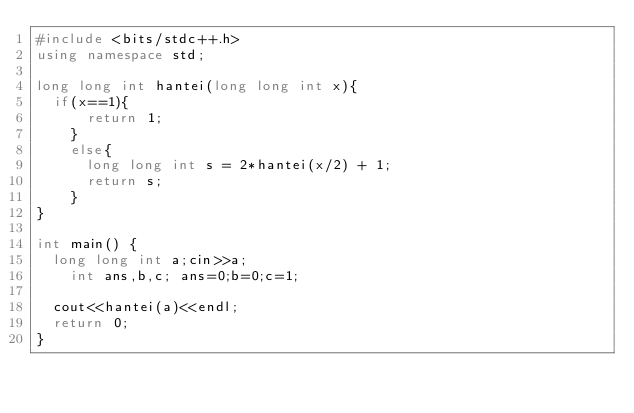Convert code to text. <code><loc_0><loc_0><loc_500><loc_500><_C++_>#include <bits/stdc++.h>
using namespace std;

long long int hantei(long long int x){
	if(x==1){
    	return 1;
    }
  	else{
    	long long int s = 2*hantei(x/2) + 1;
      return s;
    }
}

int main() {
	long long int a;cin>>a;
    int ans,b,c; ans=0;b=0;c=1;
  
	cout<<hantei(a)<<endl;
  return 0;
}</code> 